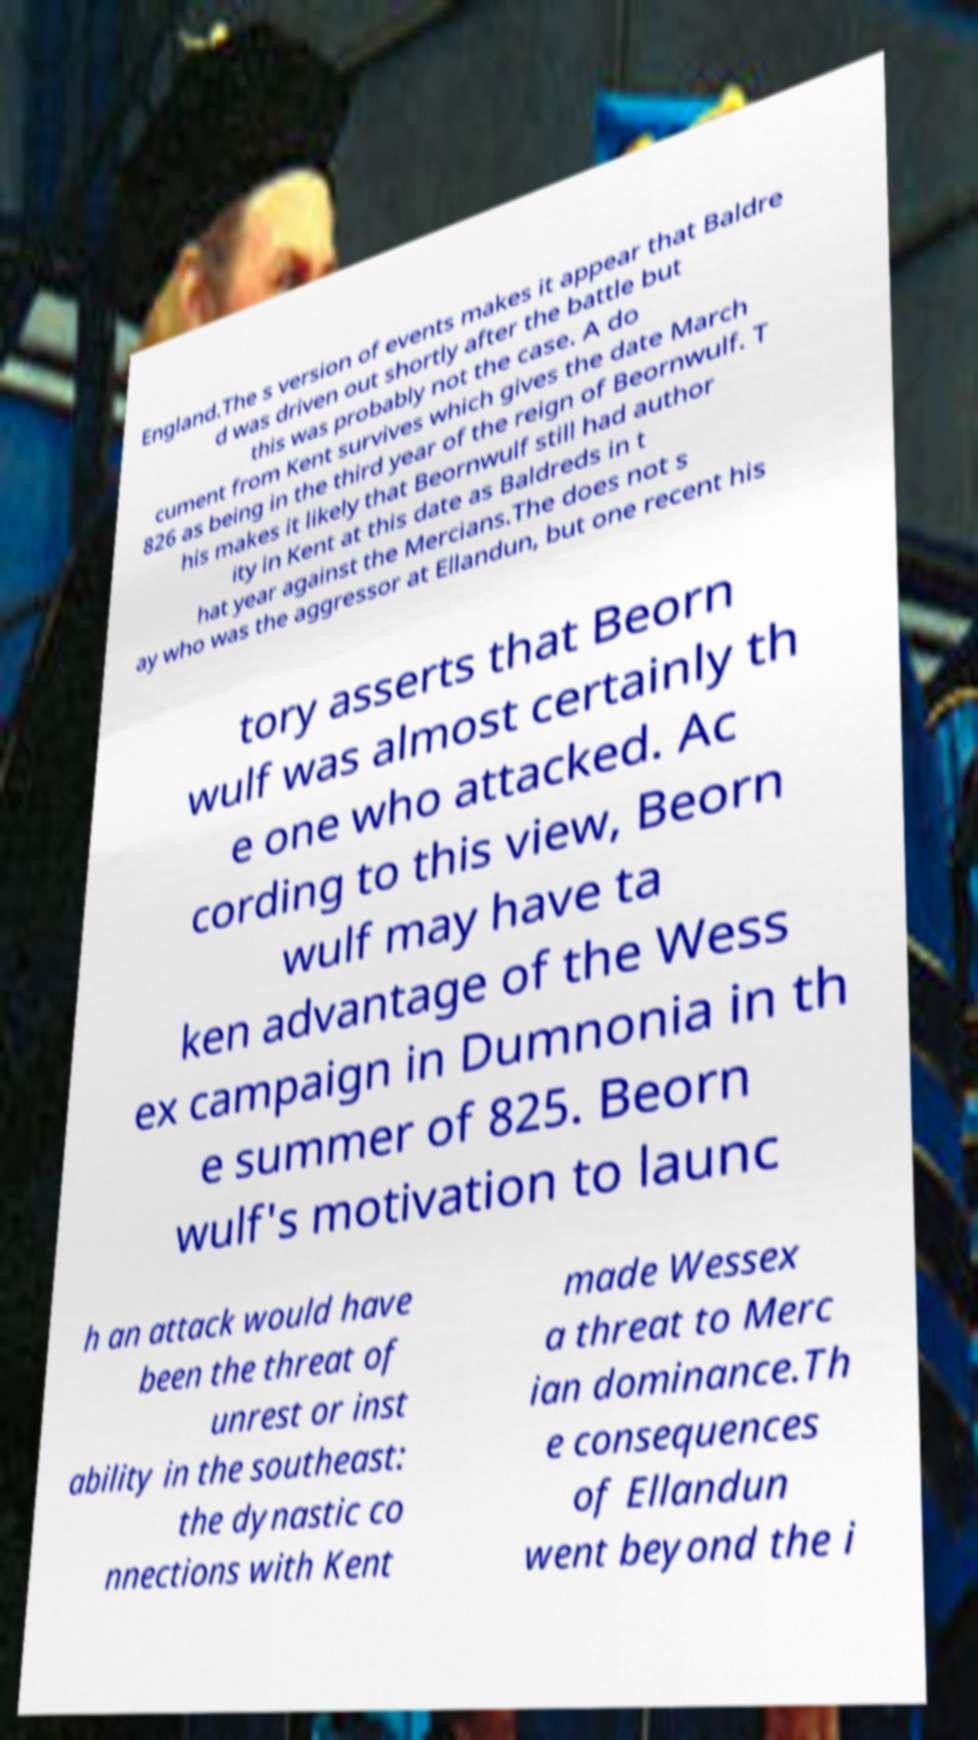Could you extract and type out the text from this image? England.The s version of events makes it appear that Baldre d was driven out shortly after the battle but this was probably not the case. A do cument from Kent survives which gives the date March 826 as being in the third year of the reign of Beornwulf. T his makes it likely that Beornwulf still had author ity in Kent at this date as Baldreds in t hat year against the Mercians.The does not s ay who was the aggressor at Ellandun, but one recent his tory asserts that Beorn wulf was almost certainly th e one who attacked. Ac cording to this view, Beorn wulf may have ta ken advantage of the Wess ex campaign in Dumnonia in th e summer of 825. Beorn wulf's motivation to launc h an attack would have been the threat of unrest or inst ability in the southeast: the dynastic co nnections with Kent made Wessex a threat to Merc ian dominance.Th e consequences of Ellandun went beyond the i 